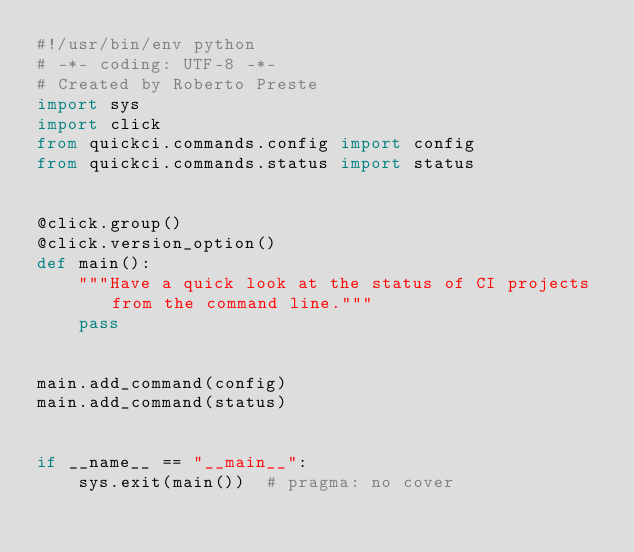<code> <loc_0><loc_0><loc_500><loc_500><_Python_>#!/usr/bin/env python
# -*- coding: UTF-8 -*-
# Created by Roberto Preste
import sys
import click
from quickci.commands.config import config
from quickci.commands.status import status


@click.group()
@click.version_option()
def main():
    """Have a quick look at the status of CI projects from the command line."""
    pass


main.add_command(config)
main.add_command(status)


if __name__ == "__main__":
    sys.exit(main())  # pragma: no cover
</code> 